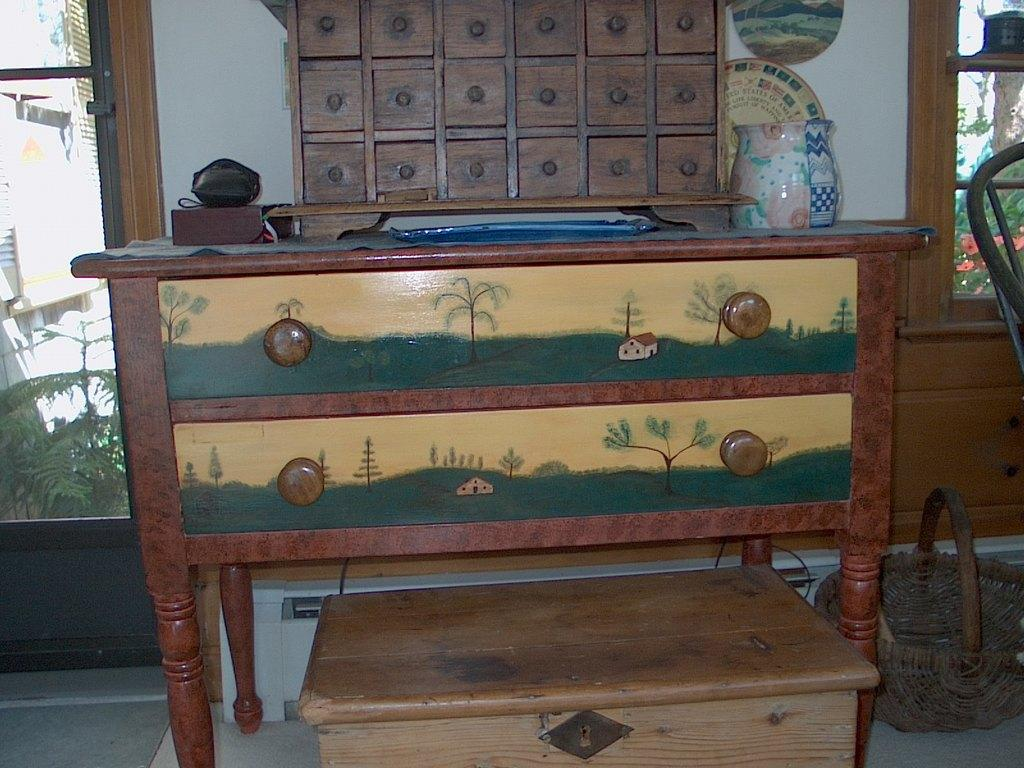What is the main piece of furniture in the image? There is a table in the image. What other types of furniture can be seen in the image? There is furniture in the image, but the specific types are not mentioned. What is located on the floor near the furniture? There is a basket on the floor. What is placed on the furniture in the image? There are objects on the furniture. What can be seen in the background of the image? There is a wall and glass windows in the background of the image. What is visible through the glass windows? Plants are visible through the glass windows. What type of rhythm is being played by the quill in the image? There is no quill or rhythm present in the image. 